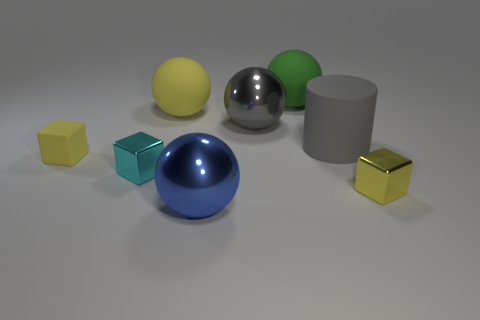Subtract all yellow balls. How many balls are left? 3 Add 1 yellow matte blocks. How many objects exist? 9 Subtract all cyan cubes. How many cubes are left? 2 Subtract all blocks. How many objects are left? 5 Subtract all yellow cylinders. How many yellow blocks are left? 2 Subtract 1 cylinders. How many cylinders are left? 0 Add 5 matte things. How many matte things are left? 9 Add 7 big gray objects. How many big gray objects exist? 9 Subtract 2 yellow blocks. How many objects are left? 6 Subtract all blue balls. Subtract all brown cylinders. How many balls are left? 3 